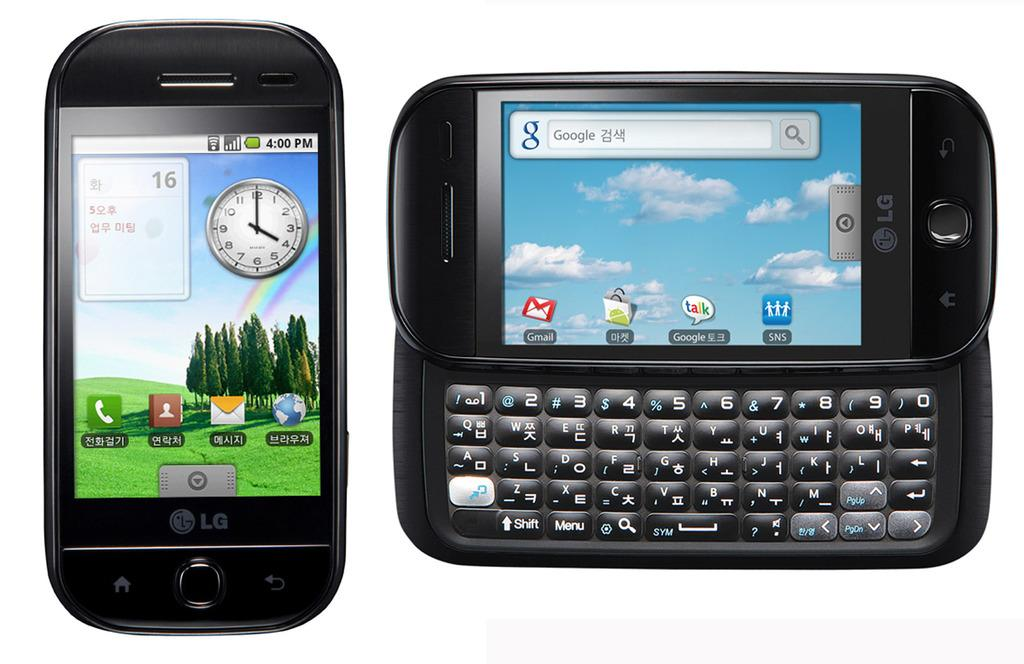Provide a one-sentence caption for the provided image. Two devices, one of which is a phone that has the number 16 visible on it. 